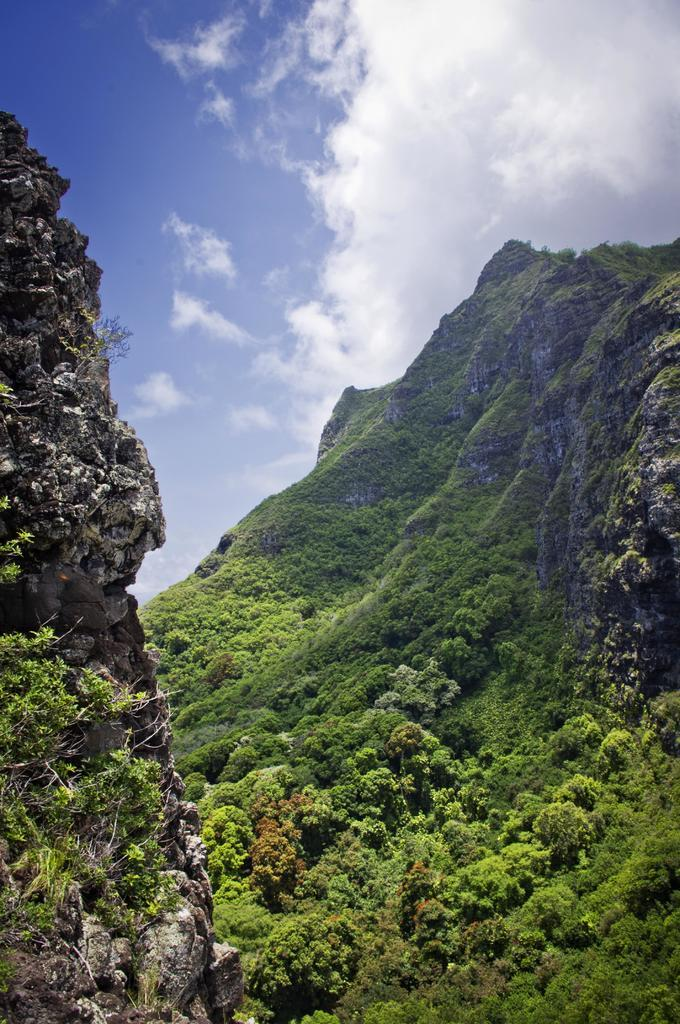What type of natural formation can be seen in the image? There are mountains in the image. What is located above the mountains? There are algae and plants above the mountains. What is visible at the top of the image? The sky is visible at the top of the image. How many lizards can be seen climbing the mountains in the image? There are no lizards present in the image. What type of tub is visible in the image? There is no tub present in the image. 